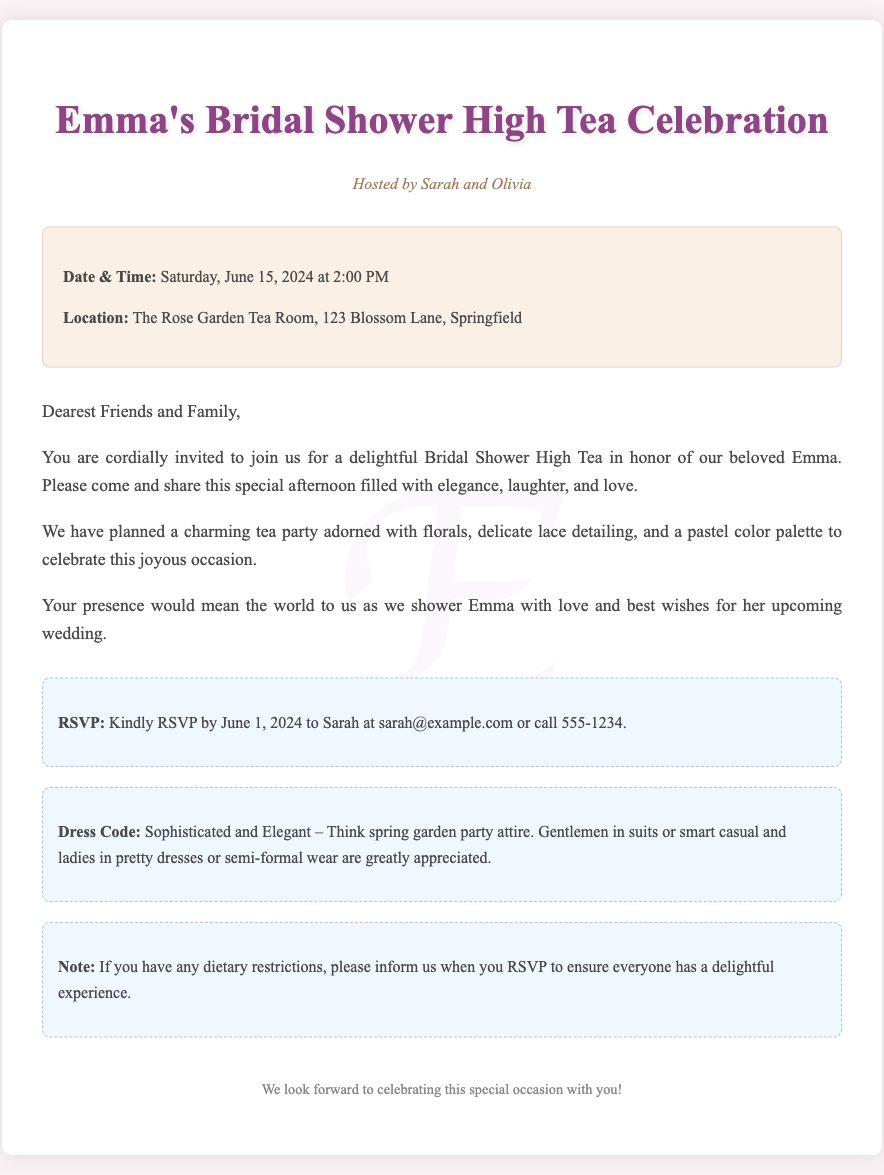What is the host's name? The host's name is mentioned as Sarah and Olivia in the subtitle.
Answer: Sarah and Olivia What date is the bridal shower being held? The date of the bridal shower is specified in the details section of the document.
Answer: Saturday, June 15, 2024 Where is the venue for the event? The location of the bridal shower is provided in the details section.
Answer: The Rose Garden Tea Room, 123 Blossom Lane, Springfield What is the RSVP deadline? The RSVP deadline is indicated in the RSVP section of the document.
Answer: June 1, 2024 What type of attire is suggested for the event? The dress code is clearly specified in the dress code section of the invitation.
Answer: Sophisticated and Elegant How should guests inform of dietary restrictions? The instruction for informing dietary restrictions is included in the notes section.
Answer: When you RSVP What main theme can be inferred for the celebration? The overall theme of the celebration is described in the message section.
Answer: Tea party What time does the event start? The start time for the bridal shower is included in the details section.
Answer: 2:00 PM 